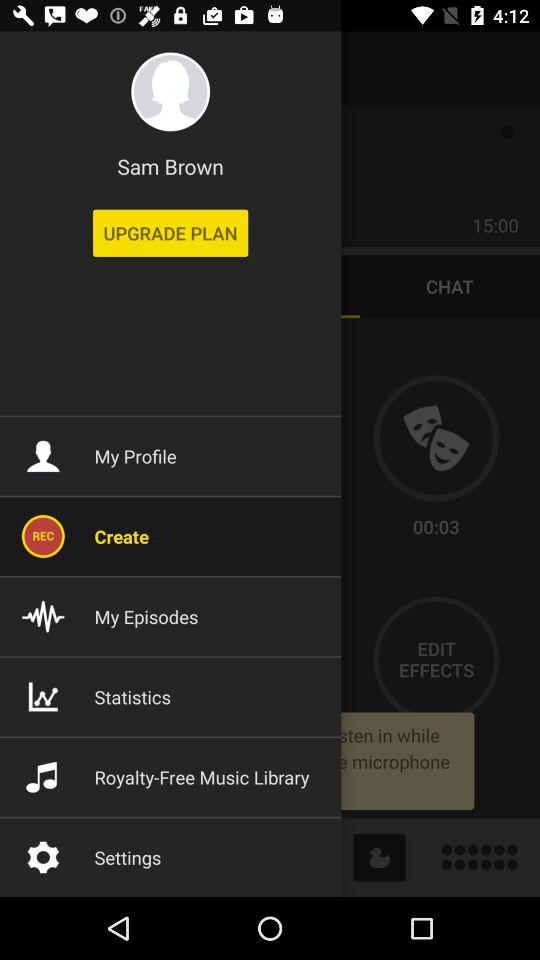Which item has been selected? The selected item is "Create". 